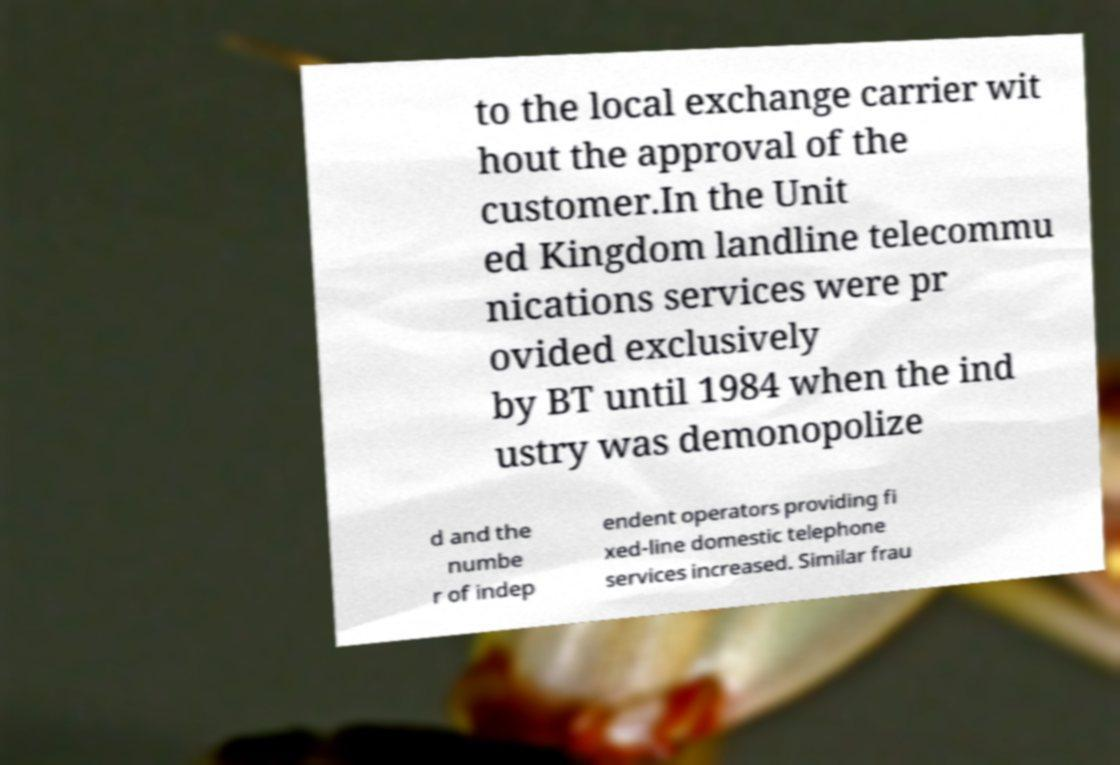Can you read and provide the text displayed in the image?This photo seems to have some interesting text. Can you extract and type it out for me? to the local exchange carrier wit hout the approval of the customer.In the Unit ed Kingdom landline telecommu nications services were pr ovided exclusively by BT until 1984 when the ind ustry was demonopolize d and the numbe r of indep endent operators providing fi xed-line domestic telephone services increased. Similar frau 